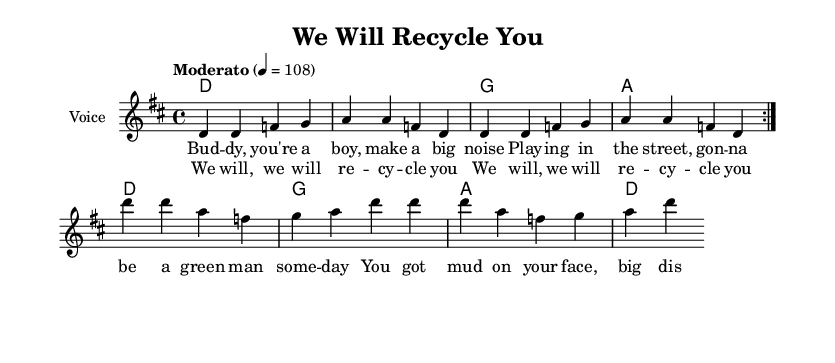What is the key signature of this music? The key signature is D major, which has two sharps: F# and C#.
Answer: D major What is the time signature? The time signature is 4/4, indicating four beats per measure.
Answer: 4/4 What is the tempo marking in the score? The tempo marking indicates a moderate speed of 108 beats per minute.
Answer: Moderato, 108 How many measures are repeated in the melody section? The melody section has a repeat indication that specifies two measures to be played again.
Answer: 2 What is the title of this piece? The title, provided at the top of the score, is "We Will Recycle You."
Answer: We Will Recycle You How many sections are present in the song structure? The score contains a verse and a chorus section, indicating at least two distinct parts.
Answer: 2 What musical form does this piece follow? The piece follows a verse-chorus structure typical in popular music formats and anthems.
Answer: Verse-chorus 